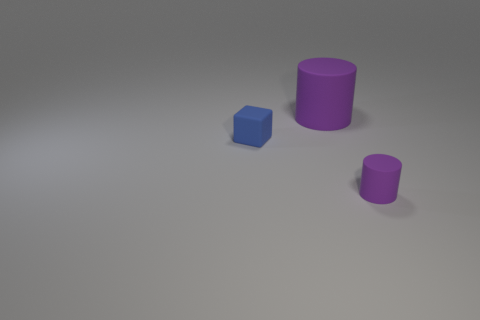What is the shape of the tiny matte thing that is the same color as the big rubber object?
Your answer should be very brief. Cylinder. Is the color of the big thing the same as the tiny rubber block?
Your answer should be compact. No. Are there any other things that have the same material as the blue cube?
Keep it short and to the point. Yes. What number of things are yellow matte objects or purple matte cylinders in front of the big rubber cylinder?
Provide a short and direct response. 1. Do the rubber object that is in front of the blue rubber cube and the blue object have the same size?
Offer a terse response. Yes. How many other things are the same shape as the blue object?
Your answer should be very brief. 0. How many blue objects are tiny blocks or big matte cylinders?
Your answer should be very brief. 1. There is a tiny thing that is in front of the rubber block; is it the same color as the rubber block?
Your answer should be very brief. No. The other big thing that is made of the same material as the blue object is what shape?
Ensure brevity in your answer.  Cylinder. The object that is both in front of the large cylinder and right of the small matte block is what color?
Offer a terse response. Purple. 